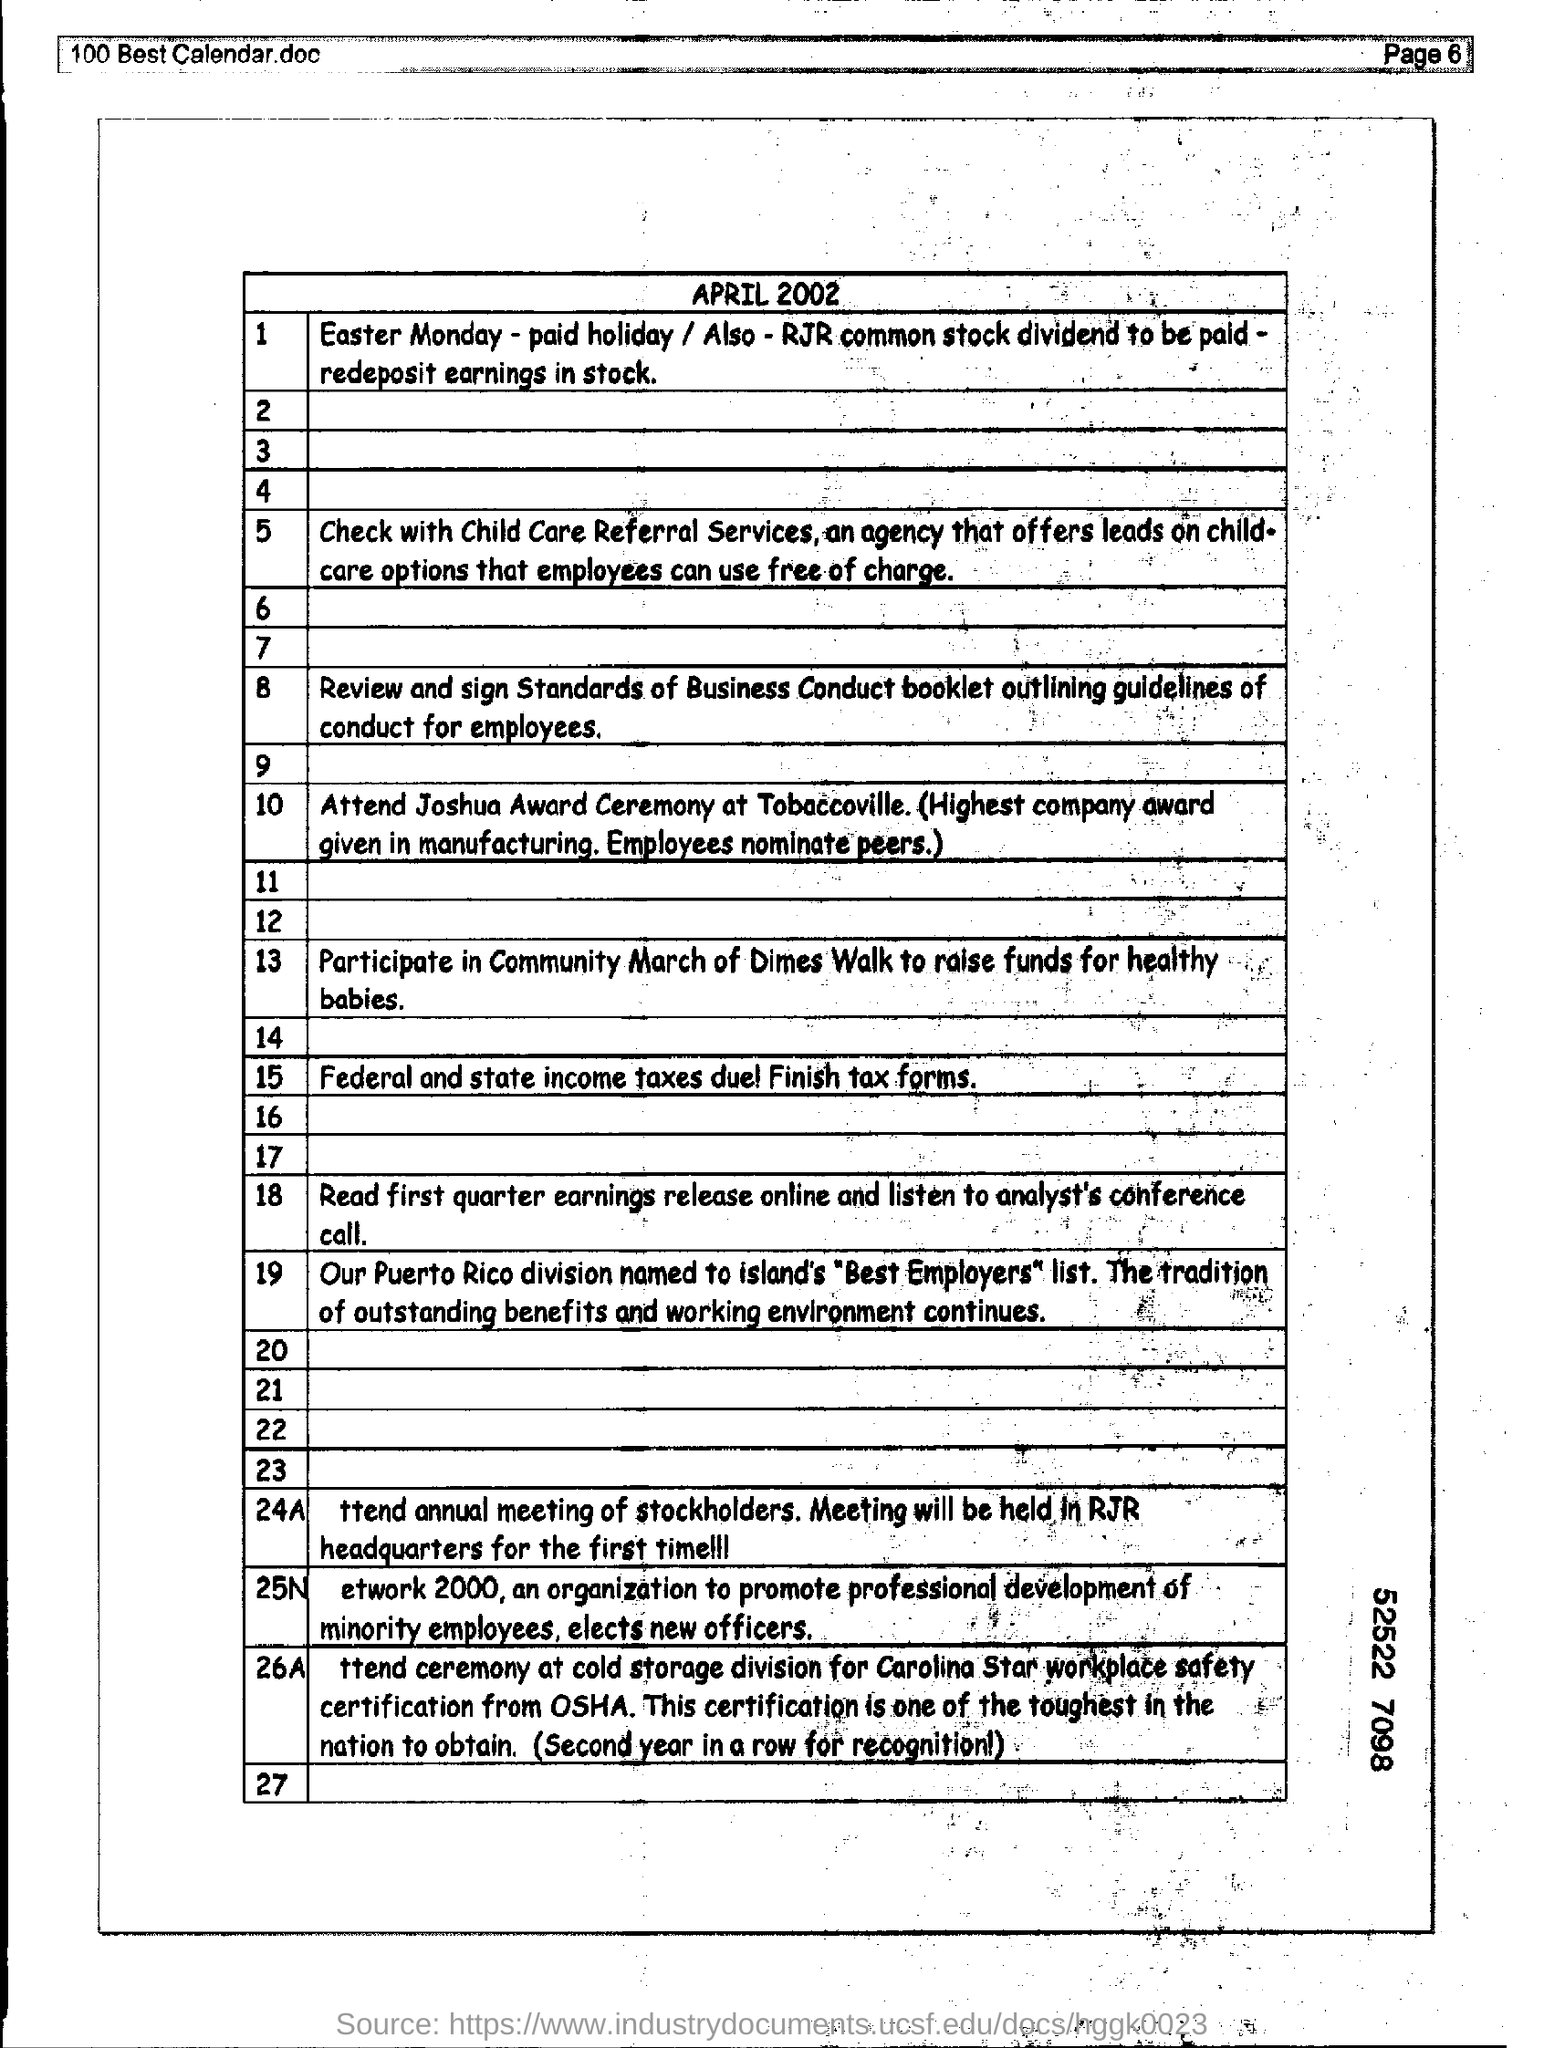Mention the page number at top right corner of the page ?
Your answer should be compact. Page 6. 